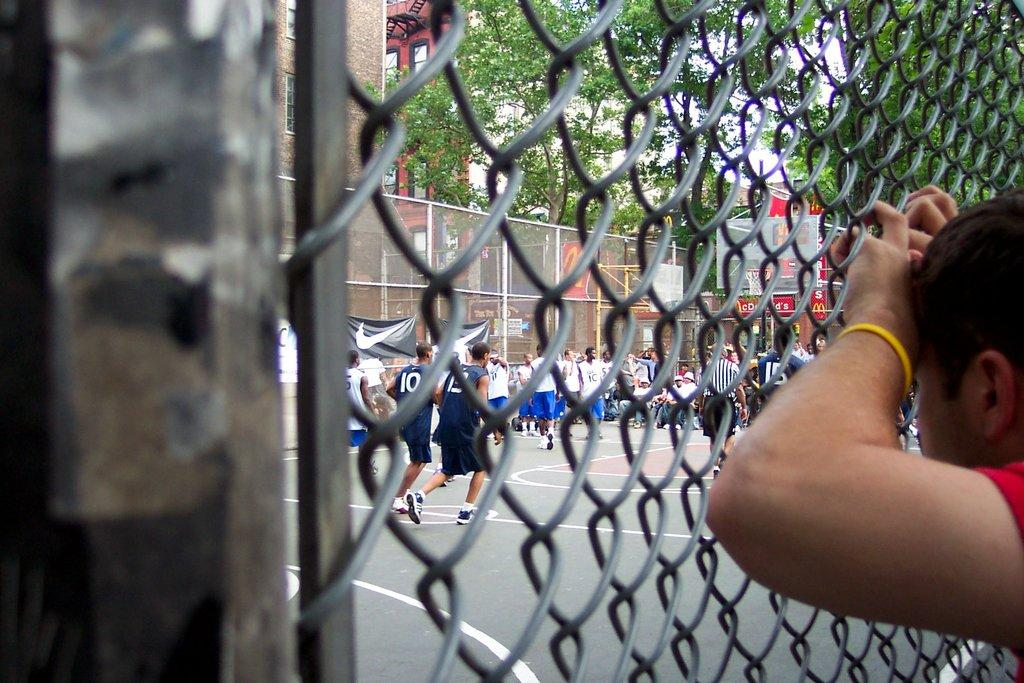How many people are in the image? There is a group of people in the image, but the exact number is not specified. What are the people in the image doing? Some people are standing, while others are running. What can be seen in the background of the image? There is a fence, trees, and buildings visible in the image. What other unspecified objects can be seen in the image? There are other unspecified objects in the image, but their nature is not described. What color are the eyes of the servant in the image? There is no servant or mention of eyes in the image; it features a group of people engaged in various activities. What phase is the moon in during the scene depicted in the image? The image does not show the moon or any celestial bodies; it focuses on the group of people and their surroundings. 